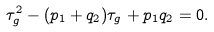<formula> <loc_0><loc_0><loc_500><loc_500>\tau _ { g } ^ { 2 } - ( p _ { 1 } + q _ { 2 } ) \tau _ { g } + p _ { 1 } q _ { 2 } = 0 .</formula> 